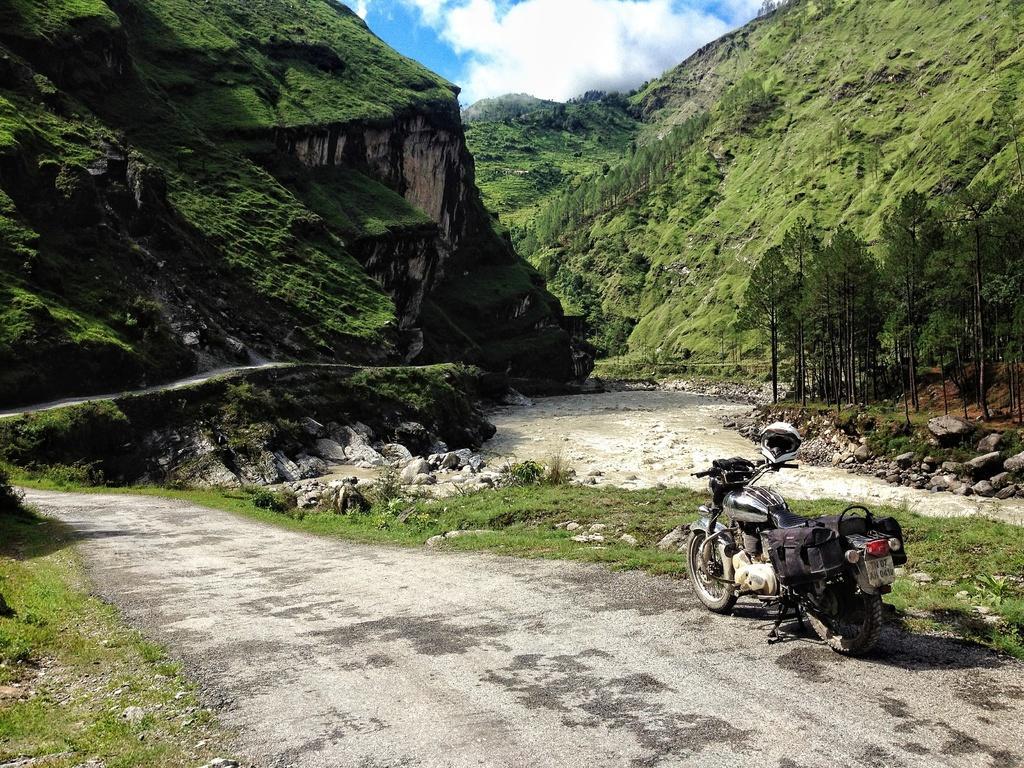In one or two sentences, can you explain what this image depicts? In this image there is a motorbike parked on the road. In the background there are hills on which there is grass. At the bottom there is a road, Beside the road there are stones. On the right side there are trees. 